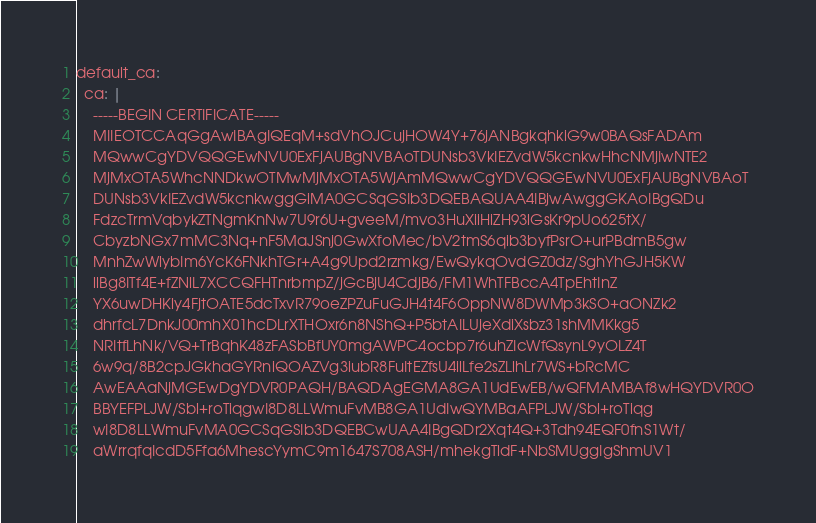<code> <loc_0><loc_0><loc_500><loc_500><_YAML_>default_ca:
  ca: |
    -----BEGIN CERTIFICATE-----
    MIIEOTCCAqGgAwIBAgIQEqM+sdVhOJCujHOW4Y+76jANBgkqhkiG9w0BAQsFADAm
    MQwwCgYDVQQGEwNVU0ExFjAUBgNVBAoTDUNsb3VkIEZvdW5kcnkwHhcNMjIwNTE2
    MjMxOTA5WhcNNDkwOTMwMjMxOTA5WjAmMQwwCgYDVQQGEwNVU0ExFjAUBgNVBAoT
    DUNsb3VkIEZvdW5kcnkwggGiMA0GCSqGSIb3DQEBAQUAA4IBjwAwggGKAoIBgQDu
    FdzcTrmVqbykZTNgmKnNw7U9r6U+gveeM/mvo3HuXiiHiZH93lGsKr9pUo625tX/
    CbyzbNGx7mMC3Nq+nF5MaJSnj0GwXfoMec/bV2tmS6qib3byfPsrO+urPBdmB5gw
    MnhZwWlybIm6YcK6FNkhTGr+A4g9Upd2rzmkg/EwQykqOvdGZ0dz/SghYhGJH5KW
    llBg8ITf4E+fZNlL7XCCQFHTnrbmpZ/jGcBjU4CdjB6/FM1WhTFBccA4TpEhtInZ
    YX6uwDHKly4FjtOATE5dcTxvR79oeZPZuFuGJH4t4F6OppNW8DWMp3kSO+aONZk2
    dhrfcL7DnkJ00mhX01hcDLrXTHOxr6n8NShQ+P5btAILUjeXdiXsbz31shMMKkg5
    NRItfLhNk/VQ+TrBqhK48zFASbBfUY0mgAWPC4ocbp7r6uhZIcWfQsynL9yOLZ4T
    6w9q/8B2cpJGkhaGYRniQOAZVg3iubR8FuItEZfsU4ilLfe2sZLlhLr7WS+bRcMC
    AwEAAaNjMGEwDgYDVR0PAQH/BAQDAgEGMA8GA1UdEwEB/wQFMAMBAf8wHQYDVR0O
    BBYEFPLJW/Sbl+roTiqgwI8D8LLWmuFvMB8GA1UdIwQYMBaAFPLJW/Sbl+roTiqg
    wI8D8LLWmuFvMA0GCSqGSIb3DQEBCwUAA4IBgQDr2Xqt4Q+3Tdh94EQF0fnS1Wt/
    aWrrqfqIcdD5Ffa6MhescYymC9m1647S708ASH/mhekgTldF+NbSMUggIgShmUV1</code> 